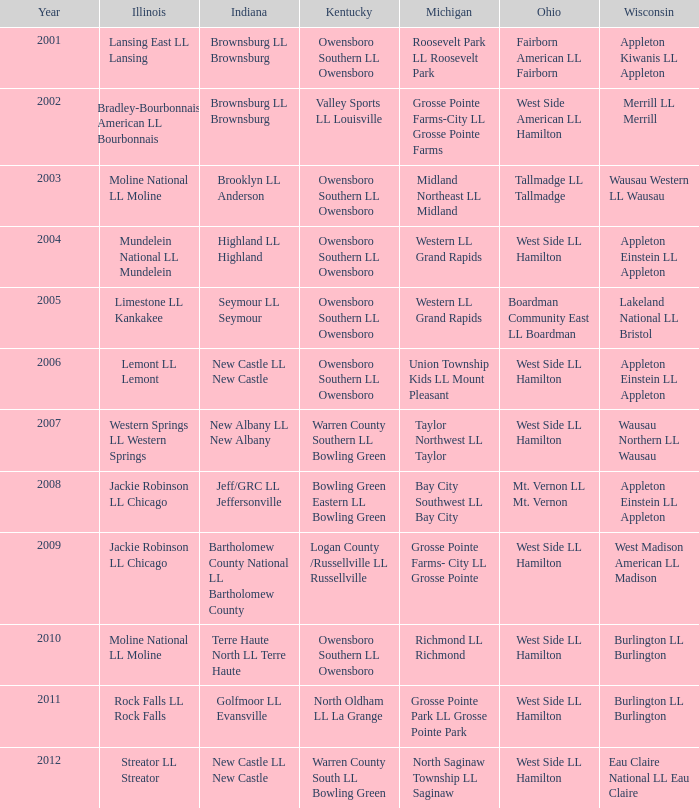What was the little league team from Kentucky when the little league team from Michigan was Grosse Pointe Farms-City LL Grosse Pointe Farms?  Valley Sports LL Louisville. 